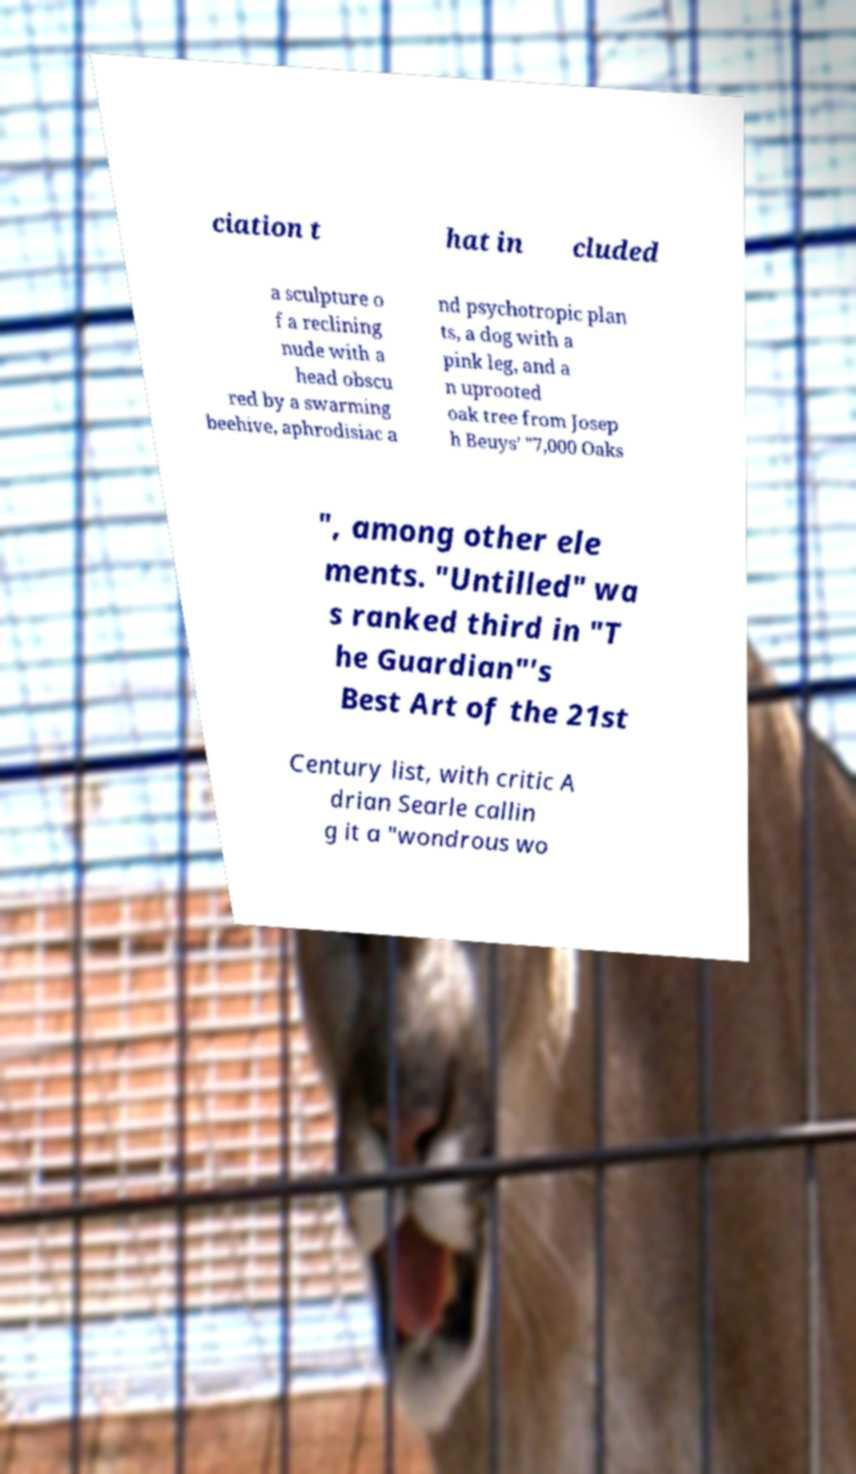Please read and relay the text visible in this image. What does it say? ciation t hat in cluded a sculpture o f a reclining nude with a head obscu red by a swarming beehive, aphrodisiac a nd psychotropic plan ts, a dog with a pink leg, and a n uprooted oak tree from Josep h Beuys’ "7,000 Oaks ", among other ele ments. "Untilled" wa s ranked third in "T he Guardian"'s Best Art of the 21st Century list, with critic A drian Searle callin g it a "wondrous wo 